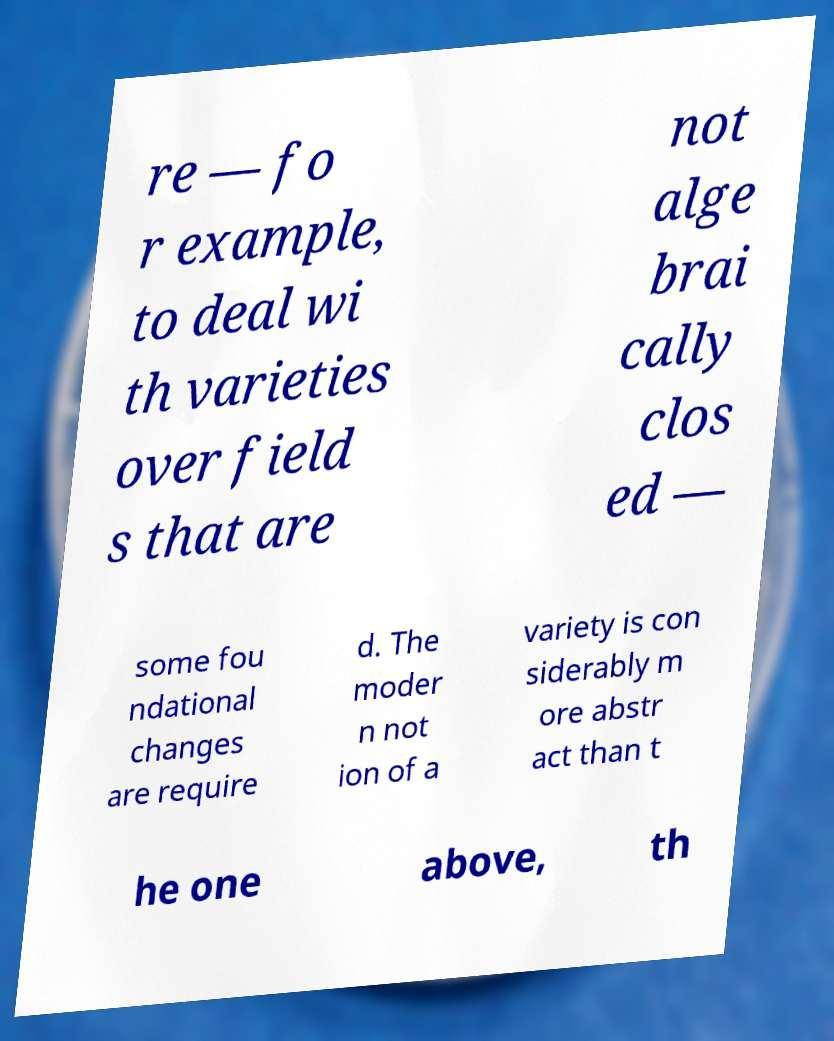Could you assist in decoding the text presented in this image and type it out clearly? re — fo r example, to deal wi th varieties over field s that are not alge brai cally clos ed — some fou ndational changes are require d. The moder n not ion of a variety is con siderably m ore abstr act than t he one above, th 